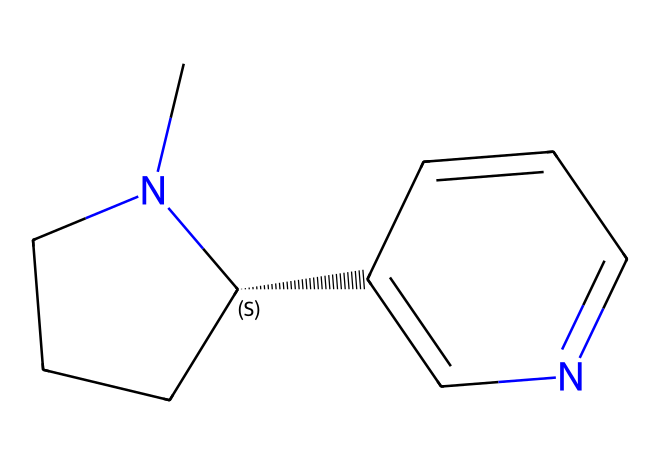What is the molecular formula of this nicotine molecule? To determine the molecular formula, count the number of each type of atom present in the SMILES representation. The molecule contains 10 carbon (C) atoms, 14 hydrogen (H) atoms, and 2 nitrogen (N) atoms, leading to the formula C10H14N2.
Answer: C10H14N2 How many double bonds are present in the structure? Analyzing the SMILES, we identify the double bonds by looking for '=' symbols. There are two double bonds present in the structure (C2=CN and C=C).
Answer: 2 What specific feature enables geometric isomerism in this nicotine molecule? Geometric isomerism occurs due to the presence of restricted rotation around carbon-carbon double bonds or certain cyclic structures. In this structure, the nitrogen atom and the connected carbons create a situation where cis and trans configurations can exist, allowing for isomerism.
Answer: double bonds Is this nicotine molecule a saturated or unsaturated compound? Saturated compounds have only single bonds between carbon atoms, while unsaturated compounds contain one or more double or triple bonds. Since this nicotine molecule has double bonds, it is classified as unsaturated.
Answer: unsaturated What are the possible geometric isomers for this nicotine compound? The geometric isomers are formed based on the arrangement around the double bonds. This nicotine molecule can exist in a cis form where substituents are on the same side, and a trans form where they are opposite each other, leading to two possible geometric isomers.
Answer: 2 What is the common name for this nicotine molecule? This particular structure corresponds to nicotine, which is a well-known alkaloid extensively studied for its effects and presence in tobacco products.
Answer: nicotine 